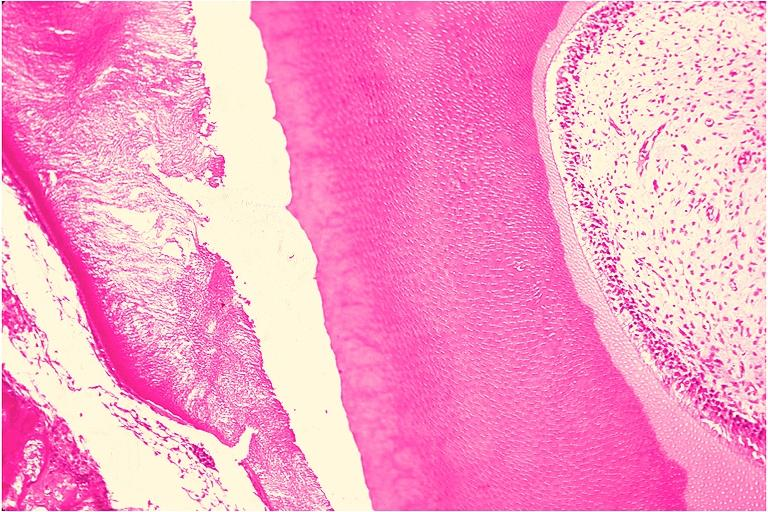s oral present?
Answer the question using a single word or phrase. Yes 